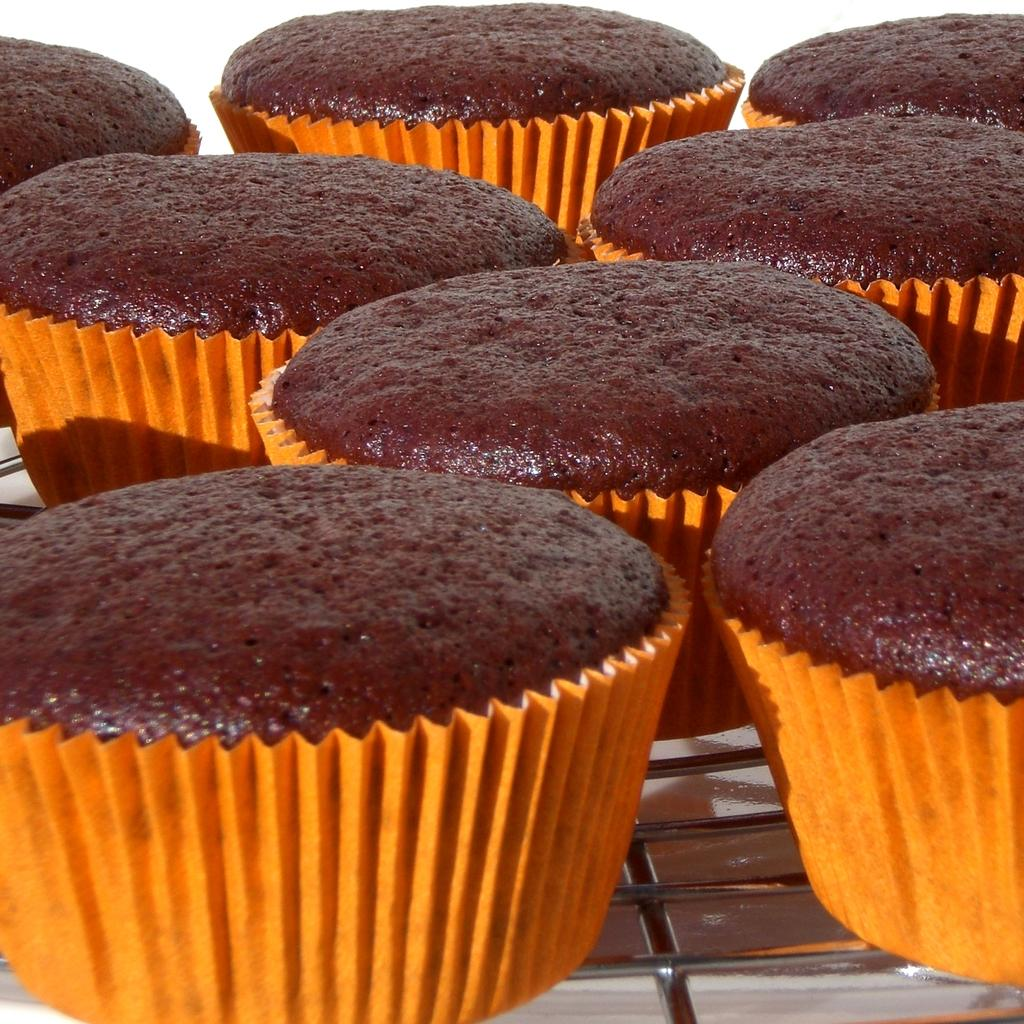What type of dessert is featured in the image? There are many cupcakes in the image. What color are the cupcakes? The cupcakes are in brown color. What color are the cupcake covers? The cupcake covers are in orange color. Is there any quicksand visible in the image? No, there is no quicksand present in the image. What type of quilt is used to cover the cupcakes in the image? There is no quilt present in the image; it features cupcakes with orange covers. 